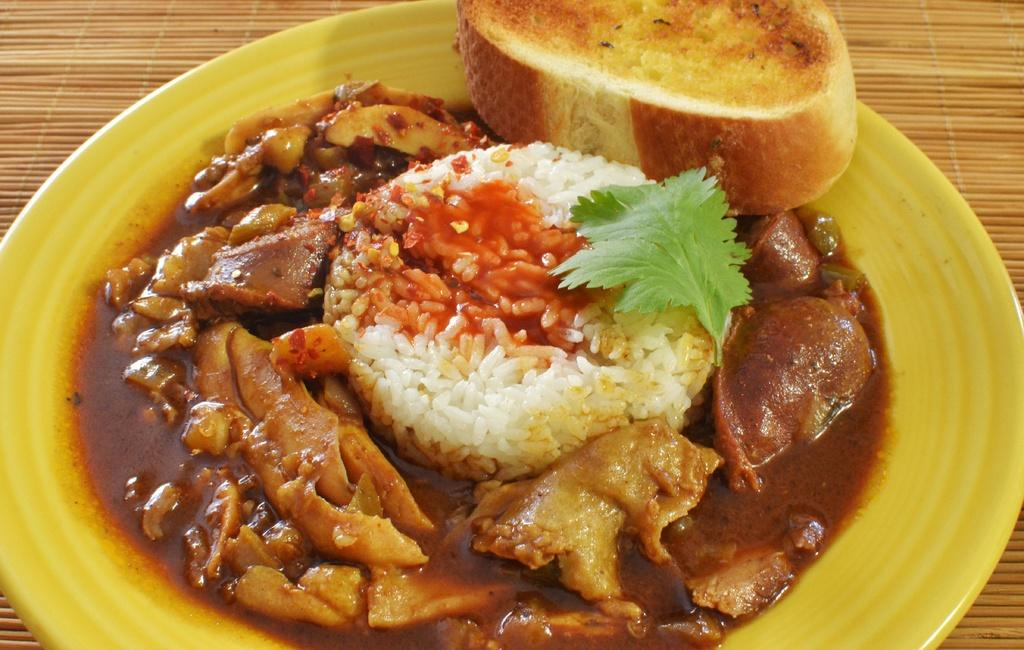What is present on the plate in the image? The food items are served on a plate in the image. Where is the plate located? The plate is on a table in the image. What type of organization is responsible for the key on the giraffe in the image? There is no giraffe or key present in the image; it only features food items served on a plate. 